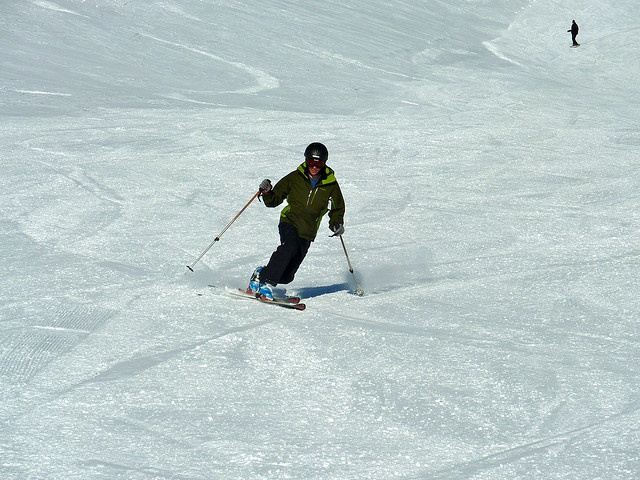Describe the objects in this image and their specific colors. I can see people in darkgray, black, lightgray, and gray tones, skis in darkgray, lightgray, gray, and black tones, and people in darkgray, black, beige, gray, and navy tones in this image. 